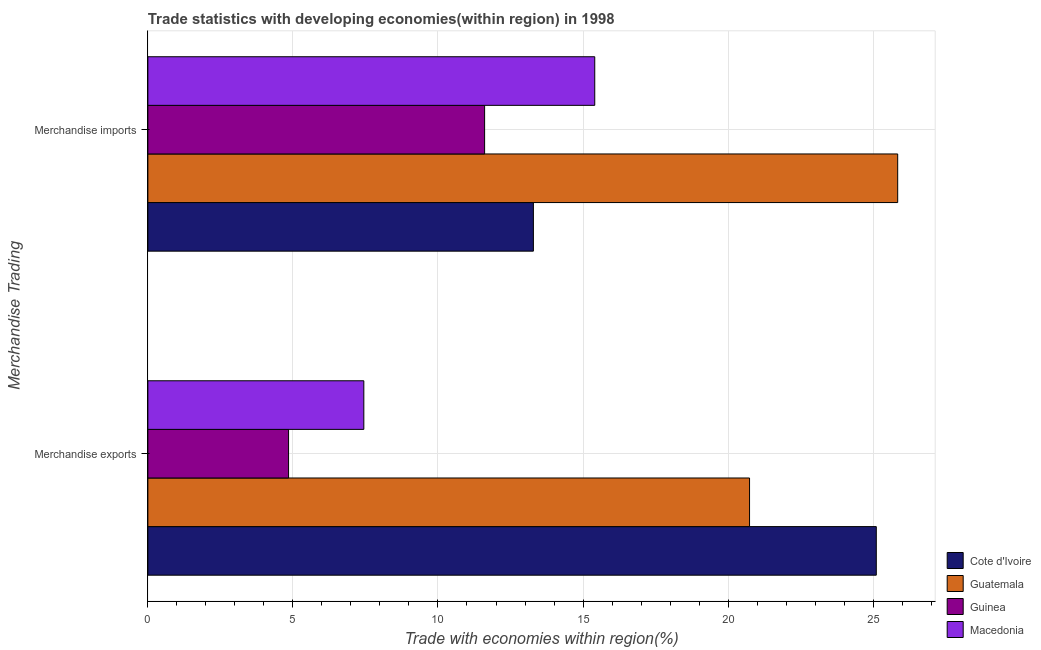How many different coloured bars are there?
Give a very brief answer. 4. How many groups of bars are there?
Give a very brief answer. 2. Are the number of bars on each tick of the Y-axis equal?
Offer a very short reply. Yes. How many bars are there on the 2nd tick from the bottom?
Keep it short and to the point. 4. What is the merchandise exports in Cote d'Ivoire?
Give a very brief answer. 25.11. Across all countries, what is the maximum merchandise imports?
Provide a succinct answer. 25.85. Across all countries, what is the minimum merchandise imports?
Provide a short and direct response. 11.61. In which country was the merchandise exports maximum?
Provide a succinct answer. Cote d'Ivoire. In which country was the merchandise exports minimum?
Offer a very short reply. Guinea. What is the total merchandise exports in the graph?
Provide a short and direct response. 58.14. What is the difference between the merchandise imports in Guatemala and that in Cote d'Ivoire?
Provide a short and direct response. 12.56. What is the difference between the merchandise exports in Guinea and the merchandise imports in Guatemala?
Keep it short and to the point. -21. What is the average merchandise exports per country?
Give a very brief answer. 14.54. What is the difference between the merchandise imports and merchandise exports in Macedonia?
Your answer should be compact. 7.96. What is the ratio of the merchandise imports in Guinea to that in Guatemala?
Your response must be concise. 0.45. Is the merchandise exports in Guinea less than that in Macedonia?
Keep it short and to the point. Yes. What does the 2nd bar from the top in Merchandise exports represents?
Give a very brief answer. Guinea. What does the 3rd bar from the bottom in Merchandise exports represents?
Your answer should be very brief. Guinea. Are all the bars in the graph horizontal?
Give a very brief answer. Yes. What is the difference between two consecutive major ticks on the X-axis?
Your answer should be compact. 5. Does the graph contain any zero values?
Your answer should be compact. No. Does the graph contain grids?
Ensure brevity in your answer.  Yes. Where does the legend appear in the graph?
Your response must be concise. Bottom right. How many legend labels are there?
Offer a very short reply. 4. How are the legend labels stacked?
Ensure brevity in your answer.  Vertical. What is the title of the graph?
Provide a succinct answer. Trade statistics with developing economies(within region) in 1998. Does "Arab World" appear as one of the legend labels in the graph?
Keep it short and to the point. No. What is the label or title of the X-axis?
Your answer should be very brief. Trade with economies within region(%). What is the label or title of the Y-axis?
Provide a short and direct response. Merchandise Trading. What is the Trade with economies within region(%) in Cote d'Ivoire in Merchandise exports?
Your response must be concise. 25.11. What is the Trade with economies within region(%) of Guatemala in Merchandise exports?
Ensure brevity in your answer.  20.74. What is the Trade with economies within region(%) of Guinea in Merchandise exports?
Keep it short and to the point. 4.85. What is the Trade with economies within region(%) of Macedonia in Merchandise exports?
Your answer should be compact. 7.44. What is the Trade with economies within region(%) of Cote d'Ivoire in Merchandise imports?
Make the answer very short. 13.29. What is the Trade with economies within region(%) of Guatemala in Merchandise imports?
Your response must be concise. 25.85. What is the Trade with economies within region(%) of Guinea in Merchandise imports?
Ensure brevity in your answer.  11.61. What is the Trade with economies within region(%) of Macedonia in Merchandise imports?
Your response must be concise. 15.4. Across all Merchandise Trading, what is the maximum Trade with economies within region(%) of Cote d'Ivoire?
Your answer should be compact. 25.11. Across all Merchandise Trading, what is the maximum Trade with economies within region(%) of Guatemala?
Offer a very short reply. 25.85. Across all Merchandise Trading, what is the maximum Trade with economies within region(%) in Guinea?
Provide a succinct answer. 11.61. Across all Merchandise Trading, what is the maximum Trade with economies within region(%) in Macedonia?
Keep it short and to the point. 15.4. Across all Merchandise Trading, what is the minimum Trade with economies within region(%) of Cote d'Ivoire?
Your answer should be very brief. 13.29. Across all Merchandise Trading, what is the minimum Trade with economies within region(%) of Guatemala?
Offer a very short reply. 20.74. Across all Merchandise Trading, what is the minimum Trade with economies within region(%) in Guinea?
Make the answer very short. 4.85. Across all Merchandise Trading, what is the minimum Trade with economies within region(%) in Macedonia?
Ensure brevity in your answer.  7.44. What is the total Trade with economies within region(%) of Cote d'Ivoire in the graph?
Offer a terse response. 38.4. What is the total Trade with economies within region(%) of Guatemala in the graph?
Your answer should be compact. 46.59. What is the total Trade with economies within region(%) of Guinea in the graph?
Provide a succinct answer. 16.46. What is the total Trade with economies within region(%) in Macedonia in the graph?
Keep it short and to the point. 22.85. What is the difference between the Trade with economies within region(%) in Cote d'Ivoire in Merchandise exports and that in Merchandise imports?
Offer a terse response. 11.82. What is the difference between the Trade with economies within region(%) in Guatemala in Merchandise exports and that in Merchandise imports?
Ensure brevity in your answer.  -5.11. What is the difference between the Trade with economies within region(%) in Guinea in Merchandise exports and that in Merchandise imports?
Ensure brevity in your answer.  -6.76. What is the difference between the Trade with economies within region(%) of Macedonia in Merchandise exports and that in Merchandise imports?
Provide a short and direct response. -7.96. What is the difference between the Trade with economies within region(%) in Cote d'Ivoire in Merchandise exports and the Trade with economies within region(%) in Guatemala in Merchandise imports?
Provide a short and direct response. -0.74. What is the difference between the Trade with economies within region(%) in Cote d'Ivoire in Merchandise exports and the Trade with economies within region(%) in Guinea in Merchandise imports?
Offer a very short reply. 13.5. What is the difference between the Trade with economies within region(%) in Cote d'Ivoire in Merchandise exports and the Trade with economies within region(%) in Macedonia in Merchandise imports?
Offer a very short reply. 9.71. What is the difference between the Trade with economies within region(%) of Guatemala in Merchandise exports and the Trade with economies within region(%) of Guinea in Merchandise imports?
Your answer should be very brief. 9.13. What is the difference between the Trade with economies within region(%) in Guatemala in Merchandise exports and the Trade with economies within region(%) in Macedonia in Merchandise imports?
Ensure brevity in your answer.  5.34. What is the difference between the Trade with economies within region(%) in Guinea in Merchandise exports and the Trade with economies within region(%) in Macedonia in Merchandise imports?
Your answer should be compact. -10.55. What is the average Trade with economies within region(%) of Cote d'Ivoire per Merchandise Trading?
Give a very brief answer. 19.2. What is the average Trade with economies within region(%) of Guatemala per Merchandise Trading?
Provide a short and direct response. 23.29. What is the average Trade with economies within region(%) in Guinea per Merchandise Trading?
Make the answer very short. 8.23. What is the average Trade with economies within region(%) of Macedonia per Merchandise Trading?
Offer a very short reply. 11.42. What is the difference between the Trade with economies within region(%) in Cote d'Ivoire and Trade with economies within region(%) in Guatemala in Merchandise exports?
Your answer should be compact. 4.37. What is the difference between the Trade with economies within region(%) of Cote d'Ivoire and Trade with economies within region(%) of Guinea in Merchandise exports?
Make the answer very short. 20.26. What is the difference between the Trade with economies within region(%) in Cote d'Ivoire and Trade with economies within region(%) in Macedonia in Merchandise exports?
Your answer should be compact. 17.66. What is the difference between the Trade with economies within region(%) in Guatemala and Trade with economies within region(%) in Guinea in Merchandise exports?
Ensure brevity in your answer.  15.89. What is the difference between the Trade with economies within region(%) of Guatemala and Trade with economies within region(%) of Macedonia in Merchandise exports?
Keep it short and to the point. 13.3. What is the difference between the Trade with economies within region(%) of Guinea and Trade with economies within region(%) of Macedonia in Merchandise exports?
Give a very brief answer. -2.59. What is the difference between the Trade with economies within region(%) of Cote d'Ivoire and Trade with economies within region(%) of Guatemala in Merchandise imports?
Keep it short and to the point. -12.56. What is the difference between the Trade with economies within region(%) of Cote d'Ivoire and Trade with economies within region(%) of Guinea in Merchandise imports?
Offer a very short reply. 1.68. What is the difference between the Trade with economies within region(%) in Cote d'Ivoire and Trade with economies within region(%) in Macedonia in Merchandise imports?
Ensure brevity in your answer.  -2.12. What is the difference between the Trade with economies within region(%) of Guatemala and Trade with economies within region(%) of Guinea in Merchandise imports?
Make the answer very short. 14.24. What is the difference between the Trade with economies within region(%) in Guatemala and Trade with economies within region(%) in Macedonia in Merchandise imports?
Provide a short and direct response. 10.44. What is the difference between the Trade with economies within region(%) in Guinea and Trade with economies within region(%) in Macedonia in Merchandise imports?
Provide a succinct answer. -3.8. What is the ratio of the Trade with economies within region(%) in Cote d'Ivoire in Merchandise exports to that in Merchandise imports?
Provide a short and direct response. 1.89. What is the ratio of the Trade with economies within region(%) in Guatemala in Merchandise exports to that in Merchandise imports?
Offer a very short reply. 0.8. What is the ratio of the Trade with economies within region(%) in Guinea in Merchandise exports to that in Merchandise imports?
Your response must be concise. 0.42. What is the ratio of the Trade with economies within region(%) in Macedonia in Merchandise exports to that in Merchandise imports?
Ensure brevity in your answer.  0.48. What is the difference between the highest and the second highest Trade with economies within region(%) in Cote d'Ivoire?
Offer a very short reply. 11.82. What is the difference between the highest and the second highest Trade with economies within region(%) in Guatemala?
Your answer should be very brief. 5.11. What is the difference between the highest and the second highest Trade with economies within region(%) in Guinea?
Give a very brief answer. 6.76. What is the difference between the highest and the second highest Trade with economies within region(%) of Macedonia?
Your answer should be compact. 7.96. What is the difference between the highest and the lowest Trade with economies within region(%) in Cote d'Ivoire?
Offer a very short reply. 11.82. What is the difference between the highest and the lowest Trade with economies within region(%) in Guatemala?
Your answer should be very brief. 5.11. What is the difference between the highest and the lowest Trade with economies within region(%) of Guinea?
Make the answer very short. 6.76. What is the difference between the highest and the lowest Trade with economies within region(%) in Macedonia?
Provide a succinct answer. 7.96. 